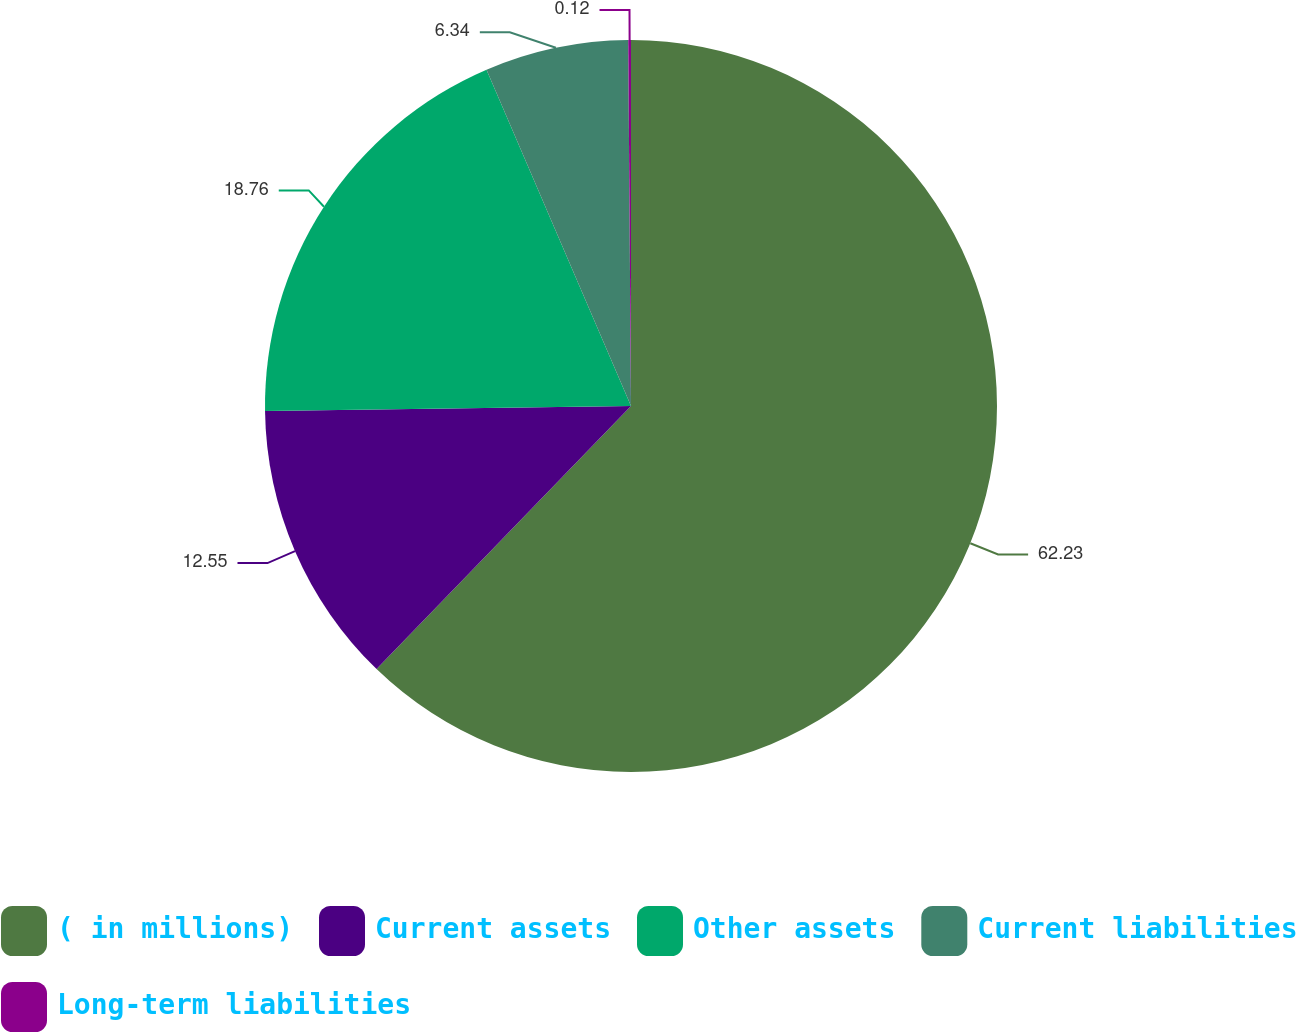Convert chart to OTSL. <chart><loc_0><loc_0><loc_500><loc_500><pie_chart><fcel>( in millions)<fcel>Current assets<fcel>Other assets<fcel>Current liabilities<fcel>Long-term liabilities<nl><fcel>62.24%<fcel>12.55%<fcel>18.76%<fcel>6.34%<fcel>0.12%<nl></chart> 